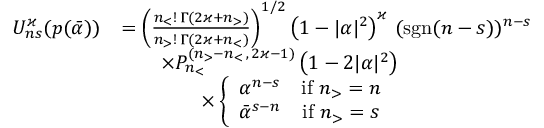<formula> <loc_0><loc_0><loc_500><loc_500>\begin{array} { r l } { U _ { n s } ^ { \varkappa } ( p ( \bar { \alpha } ) ) } & { = \left ( \frac { n _ { < } ! \, \Gamma ( 2 \varkappa + n _ { > } ) } { n _ { > } ! \, \Gamma ( 2 \varkappa + n _ { < } ) } \right ) ^ { 1 / 2 } \left ( 1 - | \alpha | ^ { 2 } \right ) ^ { \varkappa } \, ( s g n ( n - s ) ) ^ { n - s } } \\ & { \quad \times P _ { n _ { < } } ^ { ( n _ { > } - n _ { < } \, , \, 2 \varkappa - 1 ) } \left ( 1 - 2 | \alpha | ^ { 2 } \right ) \, } \\ & { \quad \times \left \{ \begin{array} { c c } { \alpha ^ { n - s } } & { i f \ n _ { > } = n } \\ { \bar { \alpha } ^ { s - n } } & { i f \ n _ { > } = s } \end{array} } \end{array}</formula> 